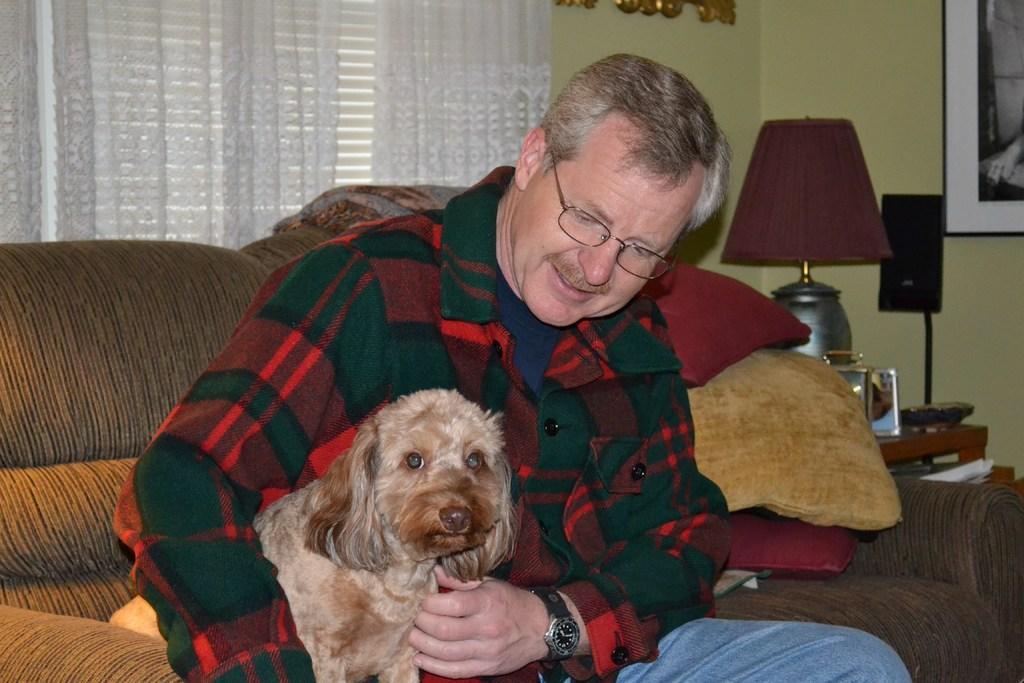In one or two sentences, can you explain what this image depicts? This is the picture of a room. In this image there is a man sitting on the sofa and there is a dog on the sofa. At the back there are cushions on the sofa and there is a lamp and there are objects on the table and there are frames on the wall and there is a curtain at the window. 